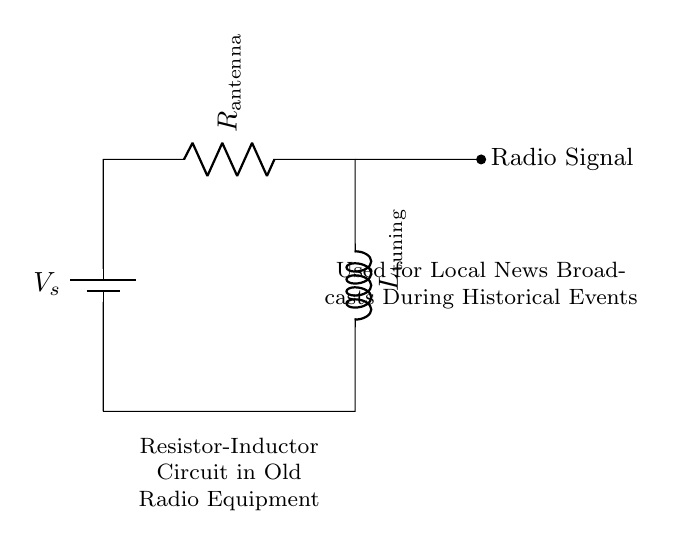What components are in this circuit? The circuit contains a battery, a resistor labeled as R antenna, and an inductor labeled as L tuning. These are the main components used for the function of the circuit in radio equipment.
Answer: Battery, R antenna, L tuning What does R antenna represent? R antenna represents the resistance component in the circuit, specifically linked to the receiving antenna. It is crucial for matching the impedance and ensuring proper signal reception for broadcasts.
Answer: Resistance What is the function of L tuning? L tuning refers to the inductor whose purpose is to select specific frequencies for tuning into radio signals. This element is essential for filtering the signals needed for broadcasting local news.
Answer: Frequency selection What type of circuit is this? This is a resistor-inductor circuit, which is a type of R-L circuit commonly used in radio applications for filtering and tuning operations.
Answer: Resistor-Inductor How does the circuit impact local news broadcasts? The circuit impacts local news broadcasts by enabling the tuning of radio signals, allowing the community to receive relevant information during historical events through effective broadcasting.
Answer: Tuning radio signals What is the role of the battery in the circuit? The battery provides the necessary voltage to energize the circuit and allow current to flow through the R and L components, enabling the operation of the radio equipment.
Answer: Provides voltage 